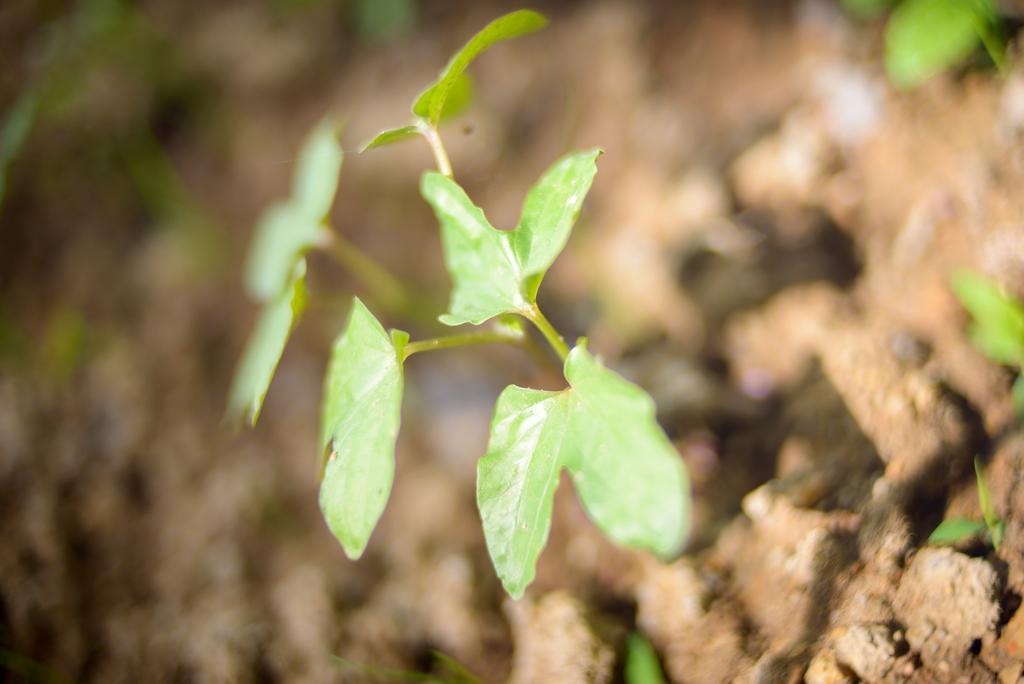How would you summarize this image in a sentence or two? In this image I can see number of green colour leaves and I can also see this image is little bit blurry. 